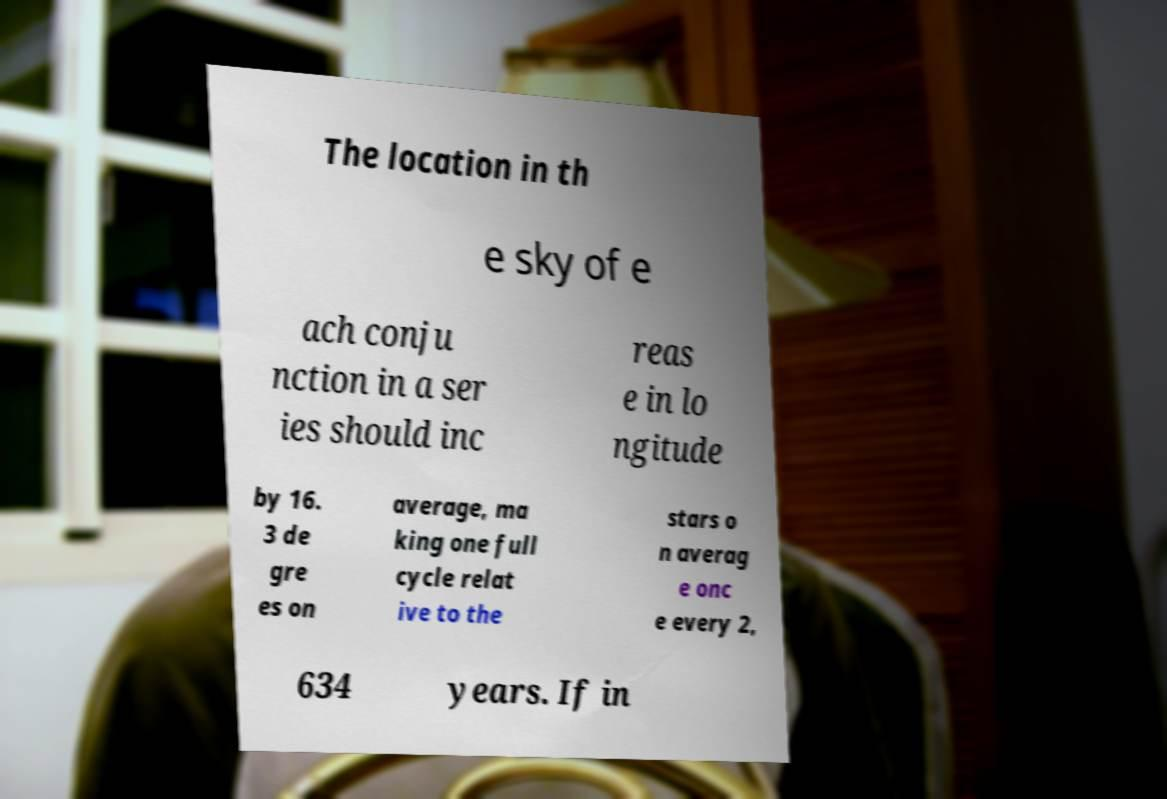There's text embedded in this image that I need extracted. Can you transcribe it verbatim? The location in th e sky of e ach conju nction in a ser ies should inc reas e in lo ngitude by 16. 3 de gre es on average, ma king one full cycle relat ive to the stars o n averag e onc e every 2, 634 years. If in 